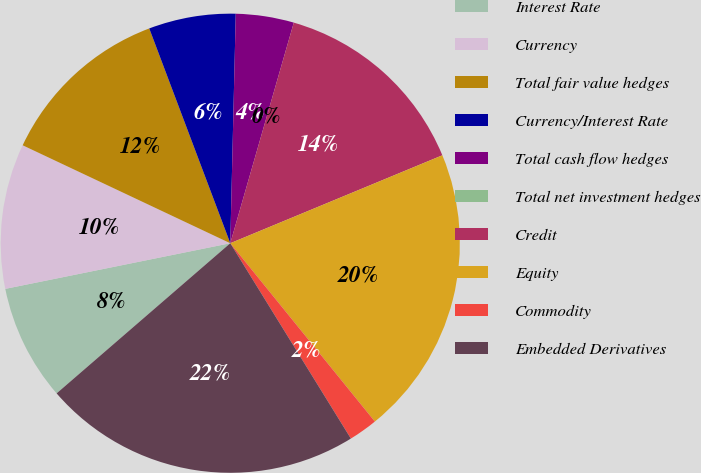<chart> <loc_0><loc_0><loc_500><loc_500><pie_chart><fcel>Interest Rate<fcel>Currency<fcel>Total fair value hedges<fcel>Currency/Interest Rate<fcel>Total cash flow hedges<fcel>Total net investment hedges<fcel>Credit<fcel>Equity<fcel>Commodity<fcel>Embedded Derivatives<nl><fcel>8.16%<fcel>10.2%<fcel>12.24%<fcel>6.12%<fcel>4.08%<fcel>0.0%<fcel>14.28%<fcel>20.41%<fcel>2.04%<fcel>22.45%<nl></chart> 